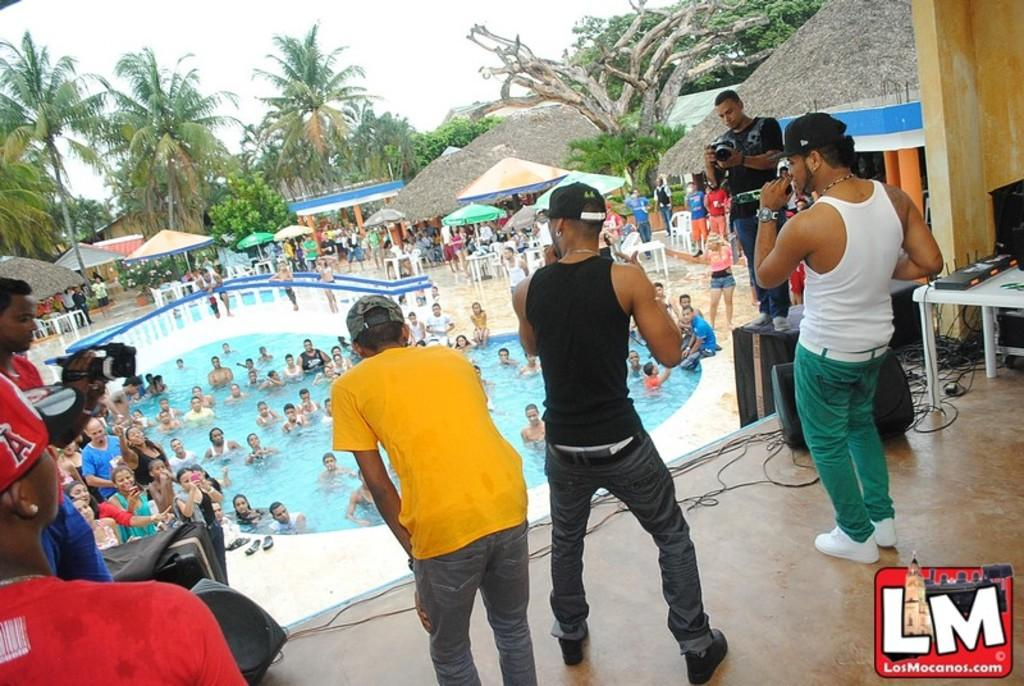What is happening on the stage in the image? There are people standing on the stage in the image. What can be seen in the background of the image? There are many people in the swimming pool in the background of the image. What objects are present in the image for providing shade? There are umbrellas in the image. What is located on the stage besides the people? There is a table on the stage in the image. What committee is meeting in the church depicted in the image? There is no church or committee meeting present in the image. How many people are kicking a ball in the image? There is no ball or kicking activity present in the image. 